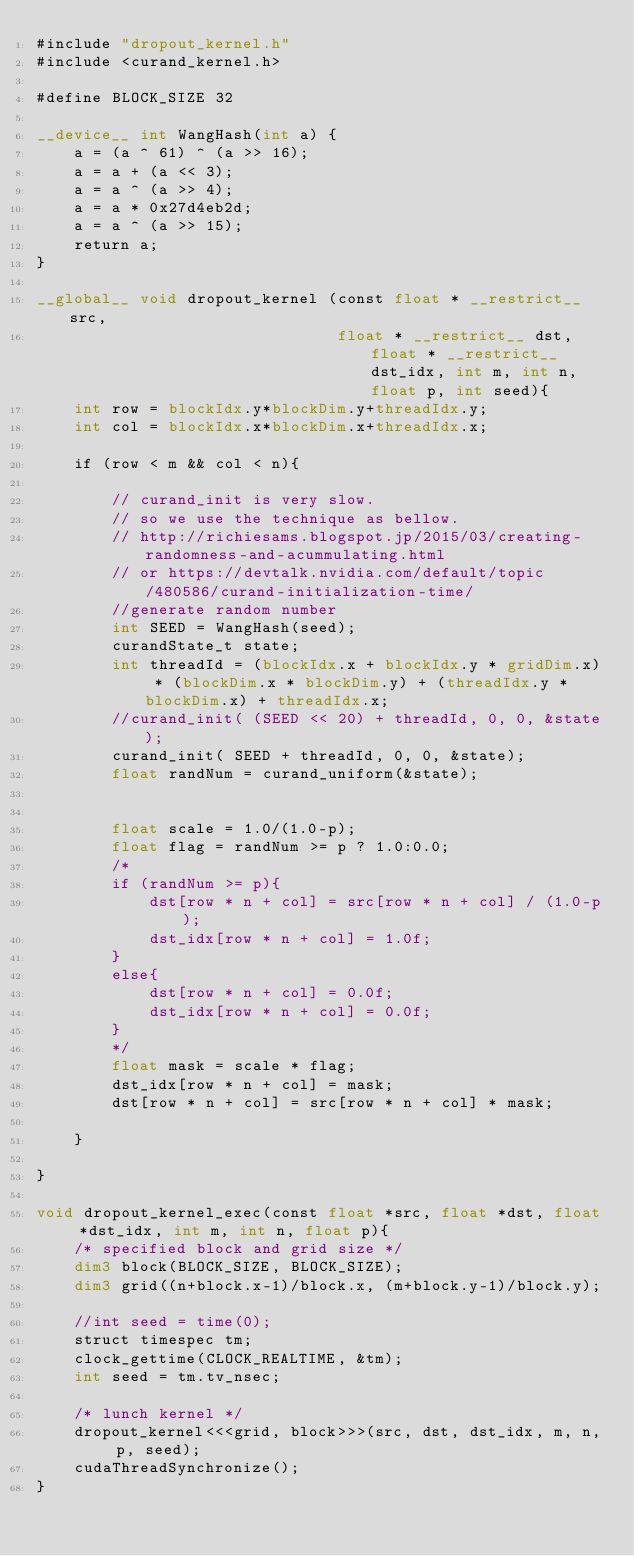<code> <loc_0><loc_0><loc_500><loc_500><_Cuda_>#include "dropout_kernel.h"
#include <curand_kernel.h>

#define BLOCK_SIZE 32

__device__ int WangHash(int a) {
    a = (a ^ 61) ^ (a >> 16);
    a = a + (a << 3);
    a = a ^ (a >> 4);
    a = a * 0x27d4eb2d;
    a = a ^ (a >> 15);
    return a;
}

__global__ void dropout_kernel (const float * __restrict__ src,
                                float * __restrict__ dst, float * __restrict__ dst_idx, int m, int n, float p, int seed){
    int row = blockIdx.y*blockDim.y+threadIdx.y;
    int col = blockIdx.x*blockDim.x+threadIdx.x;

    if (row < m && col < n){

        // curand_init is very slow.
        // so we use the technique as bellow.
        // http://richiesams.blogspot.jp/2015/03/creating-randomness-and-acummulating.html
        // or https://devtalk.nvidia.com/default/topic/480586/curand-initialization-time/
        //generate random number
        int SEED = WangHash(seed);
        curandState_t state;
        int threadId = (blockIdx.x + blockIdx.y * gridDim.x) * (blockDim.x * blockDim.y) + (threadIdx.y * blockDim.x) + threadIdx.x;
        //curand_init( (SEED << 20) + threadId, 0, 0, &state);
        curand_init( SEED + threadId, 0, 0, &state);
        float randNum = curand_uniform(&state);


        float scale = 1.0/(1.0-p);
        float flag = randNum >= p ? 1.0:0.0;
        /*
        if (randNum >= p){
            dst[row * n + col] = src[row * n + col] / (1.0-p);
            dst_idx[row * n + col] = 1.0f;
        }
        else{
            dst[row * n + col] = 0.0f;
            dst_idx[row * n + col] = 0.0f;
        }
        */
        float mask = scale * flag;
        dst_idx[row * n + col] = mask;
        dst[row * n + col] = src[row * n + col] * mask;

    }

}

void dropout_kernel_exec(const float *src, float *dst, float *dst_idx, int m, int n, float p){
    /* specified block and grid size */
    dim3 block(BLOCK_SIZE, BLOCK_SIZE);
    dim3 grid((n+block.x-1)/block.x, (m+block.y-1)/block.y);

    //int seed = time(0);
    struct timespec tm;
    clock_gettime(CLOCK_REALTIME, &tm);
    int seed = tm.tv_nsec;

    /* lunch kernel */
    dropout_kernel<<<grid, block>>>(src, dst, dst_idx, m, n, p, seed);
    cudaThreadSynchronize();
}
</code> 